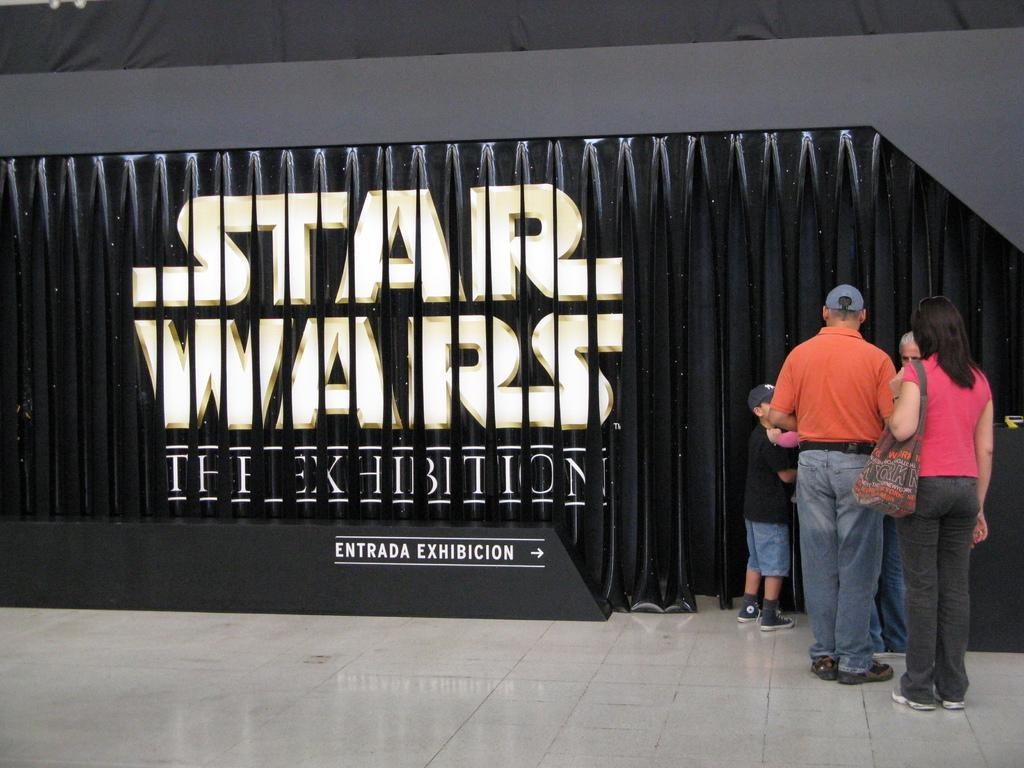Who or what can be seen in the image? There are people in the image. What is the lady in the image doing? A lady is carrying a bag in the image. What can be found on the wall in the image? There is text on a wall in the image. How many spiders are crawling on the lady's hands in the image? There are no spiders present in the image, and the lady's hands are not visible. 